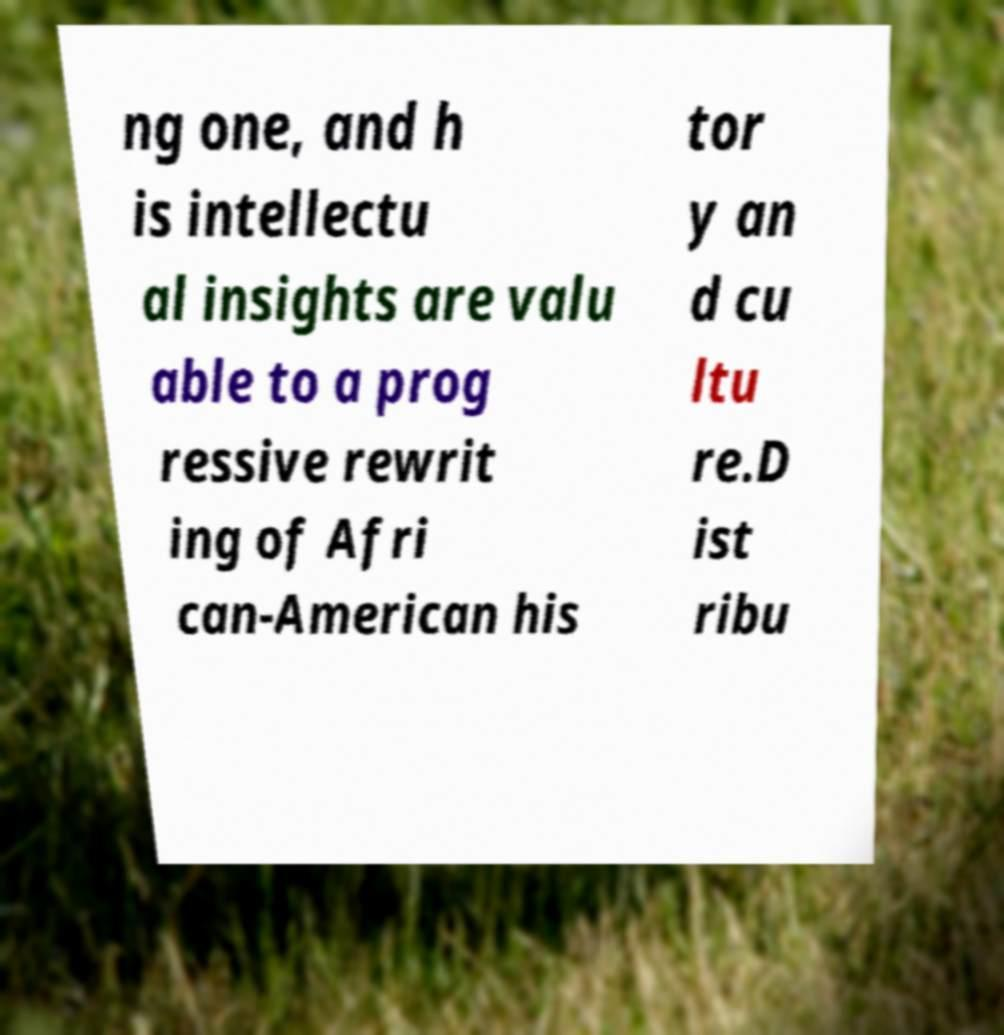For documentation purposes, I need the text within this image transcribed. Could you provide that? ng one, and h is intellectu al insights are valu able to a prog ressive rewrit ing of Afri can-American his tor y an d cu ltu re.D ist ribu 